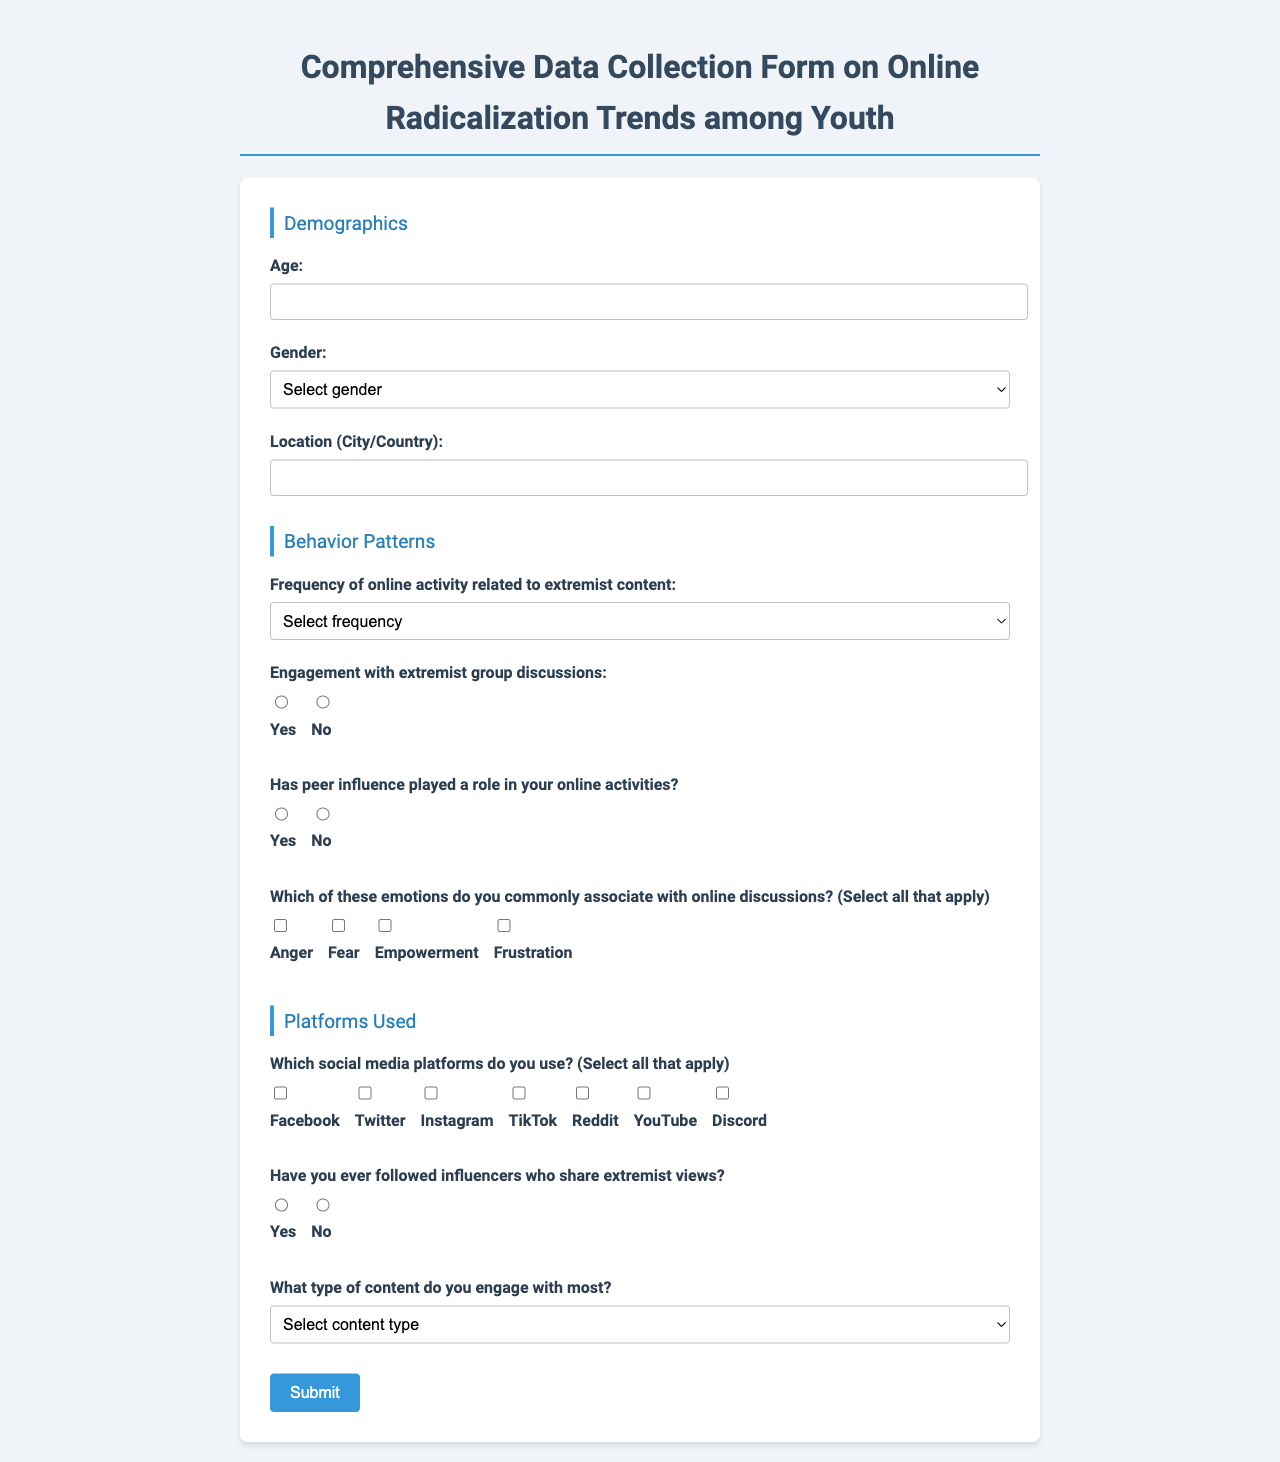What is the title of the form? The title of the form is the main heading presented at the top of the document.
Answer: Comprehensive Data Collection Form on Online Radicalization Trends among Youth How many sections are there in the form? The document contains sections that are clearly demarcated; counting them provides the total number of sections.
Answer: 3 What is the first question in the Demographics section? The first question is listed within the Demographics section, focusing on a basic information aspect.
Answer: Age What emotions can be selected in the Behavior Patterns section? The document includes a list of specific emotions that can be chosen, making it straightforward to identify them.
Answer: Anger, Fear, Empowerment, Frustration What type of content has a specific question regarding engagement? The document categorizes types of content within a specific question, guiding the respondent's engagement preference.
Answer: Content type Which platform is included as an option for online usage? The document provides a list of platforms, and one can be identified directly from that list.
Answer: Facebook How many platforms can be selected in the Platforms Used section? The question format allows for multiple selections, reflecting the options provided in the Platforms Used section.
Answer: Multiple Is there a question about peer influence? The document explicitly includes inquiries about social influences, reflecting an important aspect of radicalization behaviors.
Answer: Yes What is the required response type for the frequency question? By observing the type of input field, one can determine the format demanded for the response.
Answer: Select Have influencers with extremist views been addressed in a question? The presence of a specific question implies an exploration of engagement with extremist content sources.
Answer: Yes 